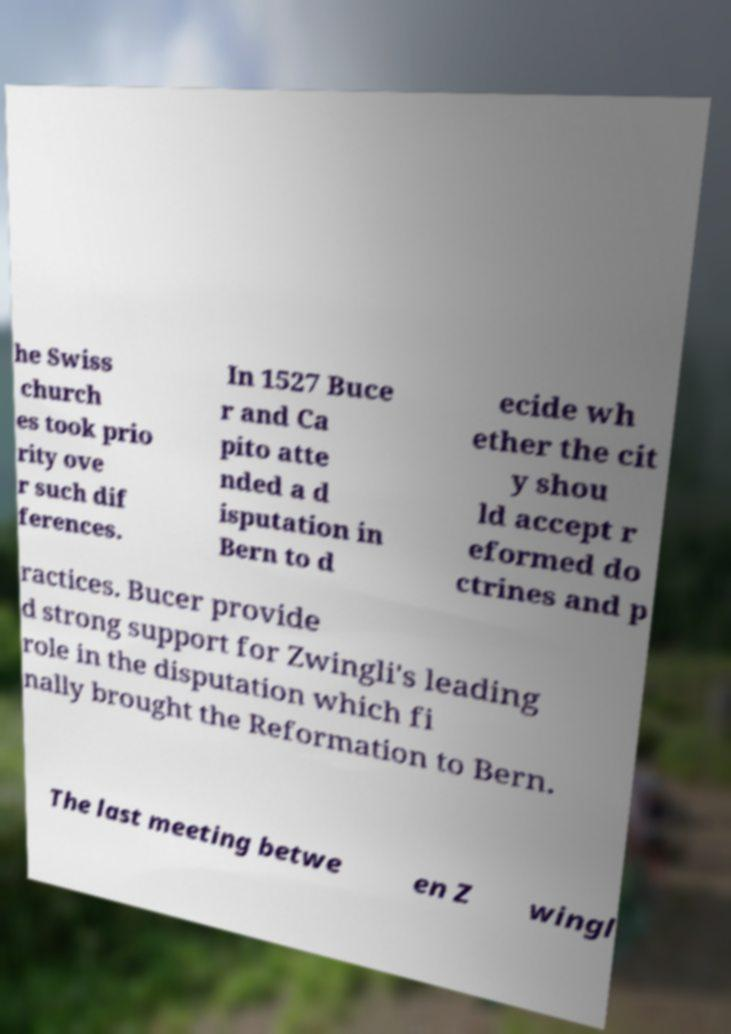There's text embedded in this image that I need extracted. Can you transcribe it verbatim? he Swiss church es took prio rity ove r such dif ferences. In 1527 Buce r and Ca pito atte nded a d isputation in Bern to d ecide wh ether the cit y shou ld accept r eformed do ctrines and p ractices. Bucer provide d strong support for Zwingli's leading role in the disputation which fi nally brought the Reformation to Bern. The last meeting betwe en Z wingl 